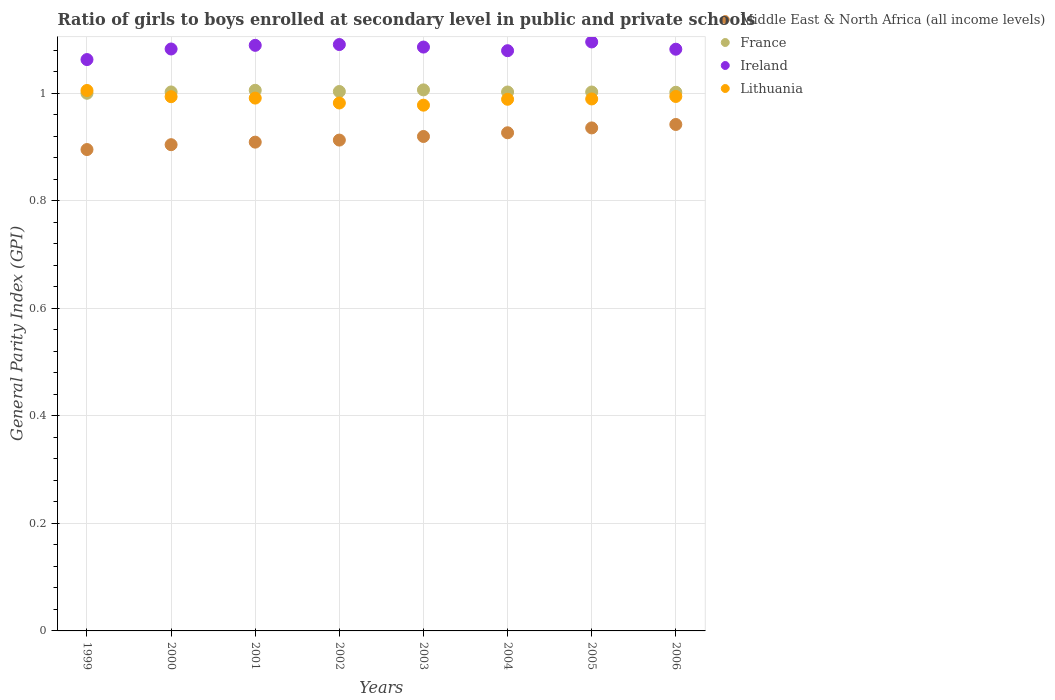How many different coloured dotlines are there?
Your answer should be very brief. 4. What is the general parity index in France in 2000?
Keep it short and to the point. 1. Across all years, what is the maximum general parity index in Middle East & North Africa (all income levels)?
Your response must be concise. 0.94. Across all years, what is the minimum general parity index in Ireland?
Provide a short and direct response. 1.06. What is the total general parity index in France in the graph?
Provide a succinct answer. 8.02. What is the difference between the general parity index in Ireland in 2002 and that in 2005?
Offer a terse response. -0. What is the difference between the general parity index in Ireland in 2006 and the general parity index in Middle East & North Africa (all income levels) in 2002?
Your answer should be very brief. 0.17. What is the average general parity index in Middle East & North Africa (all income levels) per year?
Make the answer very short. 0.92. In the year 2000, what is the difference between the general parity index in Lithuania and general parity index in Ireland?
Make the answer very short. -0.09. In how many years, is the general parity index in France greater than 0.9600000000000001?
Offer a very short reply. 8. What is the ratio of the general parity index in France in 2000 to that in 2001?
Offer a very short reply. 1. Is the difference between the general parity index in Lithuania in 1999 and 2001 greater than the difference between the general parity index in Ireland in 1999 and 2001?
Your response must be concise. Yes. What is the difference between the highest and the second highest general parity index in Lithuania?
Give a very brief answer. 0.01. What is the difference between the highest and the lowest general parity index in France?
Offer a terse response. 0.01. Is the sum of the general parity index in Lithuania in 2000 and 2006 greater than the maximum general parity index in France across all years?
Provide a short and direct response. Yes. Is it the case that in every year, the sum of the general parity index in Lithuania and general parity index in France  is greater than the sum of general parity index in Middle East & North Africa (all income levels) and general parity index in Ireland?
Make the answer very short. No. Is it the case that in every year, the sum of the general parity index in France and general parity index in Middle East & North Africa (all income levels)  is greater than the general parity index in Ireland?
Your response must be concise. Yes. Is the general parity index in Lithuania strictly less than the general parity index in Middle East & North Africa (all income levels) over the years?
Ensure brevity in your answer.  No. How many dotlines are there?
Your response must be concise. 4. Does the graph contain grids?
Your answer should be compact. Yes. Where does the legend appear in the graph?
Offer a terse response. Top right. How many legend labels are there?
Give a very brief answer. 4. How are the legend labels stacked?
Give a very brief answer. Vertical. What is the title of the graph?
Provide a succinct answer. Ratio of girls to boys enrolled at secondary level in public and private schools. Does "Gabon" appear as one of the legend labels in the graph?
Your response must be concise. No. What is the label or title of the X-axis?
Provide a short and direct response. Years. What is the label or title of the Y-axis?
Your answer should be compact. General Parity Index (GPI). What is the General Parity Index (GPI) of Middle East & North Africa (all income levels) in 1999?
Ensure brevity in your answer.  0.9. What is the General Parity Index (GPI) in France in 1999?
Your answer should be very brief. 1. What is the General Parity Index (GPI) in Ireland in 1999?
Offer a very short reply. 1.06. What is the General Parity Index (GPI) of Lithuania in 1999?
Offer a very short reply. 1. What is the General Parity Index (GPI) in Middle East & North Africa (all income levels) in 2000?
Keep it short and to the point. 0.9. What is the General Parity Index (GPI) of France in 2000?
Give a very brief answer. 1. What is the General Parity Index (GPI) in Ireland in 2000?
Give a very brief answer. 1.08. What is the General Parity Index (GPI) in Lithuania in 2000?
Offer a terse response. 0.99. What is the General Parity Index (GPI) of Middle East & North Africa (all income levels) in 2001?
Your answer should be compact. 0.91. What is the General Parity Index (GPI) in France in 2001?
Provide a short and direct response. 1.01. What is the General Parity Index (GPI) in Ireland in 2001?
Provide a succinct answer. 1.09. What is the General Parity Index (GPI) in Lithuania in 2001?
Provide a short and direct response. 0.99. What is the General Parity Index (GPI) of Middle East & North Africa (all income levels) in 2002?
Keep it short and to the point. 0.91. What is the General Parity Index (GPI) of France in 2002?
Offer a very short reply. 1. What is the General Parity Index (GPI) in Ireland in 2002?
Make the answer very short. 1.09. What is the General Parity Index (GPI) of Lithuania in 2002?
Make the answer very short. 0.98. What is the General Parity Index (GPI) of Middle East & North Africa (all income levels) in 2003?
Provide a short and direct response. 0.92. What is the General Parity Index (GPI) in France in 2003?
Provide a short and direct response. 1.01. What is the General Parity Index (GPI) of Ireland in 2003?
Provide a succinct answer. 1.09. What is the General Parity Index (GPI) in Lithuania in 2003?
Give a very brief answer. 0.98. What is the General Parity Index (GPI) in Middle East & North Africa (all income levels) in 2004?
Your answer should be very brief. 0.93. What is the General Parity Index (GPI) in France in 2004?
Your answer should be compact. 1. What is the General Parity Index (GPI) of Ireland in 2004?
Your answer should be very brief. 1.08. What is the General Parity Index (GPI) in Lithuania in 2004?
Keep it short and to the point. 0.99. What is the General Parity Index (GPI) of Middle East & North Africa (all income levels) in 2005?
Make the answer very short. 0.94. What is the General Parity Index (GPI) of France in 2005?
Provide a succinct answer. 1. What is the General Parity Index (GPI) of Ireland in 2005?
Your answer should be very brief. 1.1. What is the General Parity Index (GPI) in Lithuania in 2005?
Your answer should be very brief. 0.99. What is the General Parity Index (GPI) of Middle East & North Africa (all income levels) in 2006?
Your answer should be very brief. 0.94. What is the General Parity Index (GPI) in France in 2006?
Provide a short and direct response. 1. What is the General Parity Index (GPI) in Ireland in 2006?
Your answer should be very brief. 1.08. What is the General Parity Index (GPI) in Lithuania in 2006?
Offer a very short reply. 0.99. Across all years, what is the maximum General Parity Index (GPI) in Middle East & North Africa (all income levels)?
Make the answer very short. 0.94. Across all years, what is the maximum General Parity Index (GPI) in France?
Your answer should be very brief. 1.01. Across all years, what is the maximum General Parity Index (GPI) in Ireland?
Your answer should be compact. 1.1. Across all years, what is the maximum General Parity Index (GPI) in Lithuania?
Provide a succinct answer. 1. Across all years, what is the minimum General Parity Index (GPI) of Middle East & North Africa (all income levels)?
Offer a very short reply. 0.9. Across all years, what is the minimum General Parity Index (GPI) in France?
Your answer should be very brief. 1. Across all years, what is the minimum General Parity Index (GPI) of Ireland?
Offer a very short reply. 1.06. Across all years, what is the minimum General Parity Index (GPI) of Lithuania?
Offer a very short reply. 0.98. What is the total General Parity Index (GPI) of Middle East & North Africa (all income levels) in the graph?
Ensure brevity in your answer.  7.34. What is the total General Parity Index (GPI) in France in the graph?
Offer a terse response. 8.02. What is the total General Parity Index (GPI) of Ireland in the graph?
Provide a succinct answer. 8.66. What is the total General Parity Index (GPI) of Lithuania in the graph?
Make the answer very short. 7.92. What is the difference between the General Parity Index (GPI) in Middle East & North Africa (all income levels) in 1999 and that in 2000?
Your answer should be very brief. -0.01. What is the difference between the General Parity Index (GPI) of France in 1999 and that in 2000?
Offer a terse response. -0. What is the difference between the General Parity Index (GPI) in Ireland in 1999 and that in 2000?
Provide a succinct answer. -0.02. What is the difference between the General Parity Index (GPI) in Lithuania in 1999 and that in 2000?
Keep it short and to the point. 0.01. What is the difference between the General Parity Index (GPI) in Middle East & North Africa (all income levels) in 1999 and that in 2001?
Provide a short and direct response. -0.01. What is the difference between the General Parity Index (GPI) in France in 1999 and that in 2001?
Provide a short and direct response. -0.01. What is the difference between the General Parity Index (GPI) in Ireland in 1999 and that in 2001?
Offer a very short reply. -0.03. What is the difference between the General Parity Index (GPI) of Lithuania in 1999 and that in 2001?
Ensure brevity in your answer.  0.01. What is the difference between the General Parity Index (GPI) of Middle East & North Africa (all income levels) in 1999 and that in 2002?
Your response must be concise. -0.02. What is the difference between the General Parity Index (GPI) in France in 1999 and that in 2002?
Provide a short and direct response. -0. What is the difference between the General Parity Index (GPI) in Ireland in 1999 and that in 2002?
Your answer should be compact. -0.03. What is the difference between the General Parity Index (GPI) of Lithuania in 1999 and that in 2002?
Provide a succinct answer. 0.02. What is the difference between the General Parity Index (GPI) of Middle East & North Africa (all income levels) in 1999 and that in 2003?
Offer a terse response. -0.02. What is the difference between the General Parity Index (GPI) of France in 1999 and that in 2003?
Provide a short and direct response. -0.01. What is the difference between the General Parity Index (GPI) of Ireland in 1999 and that in 2003?
Ensure brevity in your answer.  -0.02. What is the difference between the General Parity Index (GPI) of Lithuania in 1999 and that in 2003?
Your response must be concise. 0.03. What is the difference between the General Parity Index (GPI) of Middle East & North Africa (all income levels) in 1999 and that in 2004?
Offer a terse response. -0.03. What is the difference between the General Parity Index (GPI) of France in 1999 and that in 2004?
Keep it short and to the point. -0. What is the difference between the General Parity Index (GPI) of Ireland in 1999 and that in 2004?
Provide a succinct answer. -0.02. What is the difference between the General Parity Index (GPI) of Lithuania in 1999 and that in 2004?
Offer a very short reply. 0.02. What is the difference between the General Parity Index (GPI) in Middle East & North Africa (all income levels) in 1999 and that in 2005?
Offer a very short reply. -0.04. What is the difference between the General Parity Index (GPI) in France in 1999 and that in 2005?
Give a very brief answer. -0. What is the difference between the General Parity Index (GPI) of Ireland in 1999 and that in 2005?
Offer a terse response. -0.03. What is the difference between the General Parity Index (GPI) in Lithuania in 1999 and that in 2005?
Your answer should be very brief. 0.02. What is the difference between the General Parity Index (GPI) in Middle East & North Africa (all income levels) in 1999 and that in 2006?
Provide a succinct answer. -0.05. What is the difference between the General Parity Index (GPI) of France in 1999 and that in 2006?
Make the answer very short. -0. What is the difference between the General Parity Index (GPI) of Ireland in 1999 and that in 2006?
Provide a short and direct response. -0.02. What is the difference between the General Parity Index (GPI) in Lithuania in 1999 and that in 2006?
Provide a succinct answer. 0.01. What is the difference between the General Parity Index (GPI) of Middle East & North Africa (all income levels) in 2000 and that in 2001?
Your answer should be compact. -0. What is the difference between the General Parity Index (GPI) of France in 2000 and that in 2001?
Offer a very short reply. -0. What is the difference between the General Parity Index (GPI) of Ireland in 2000 and that in 2001?
Your response must be concise. -0.01. What is the difference between the General Parity Index (GPI) of Lithuania in 2000 and that in 2001?
Ensure brevity in your answer.  0. What is the difference between the General Parity Index (GPI) in Middle East & North Africa (all income levels) in 2000 and that in 2002?
Keep it short and to the point. -0.01. What is the difference between the General Parity Index (GPI) of France in 2000 and that in 2002?
Keep it short and to the point. -0. What is the difference between the General Parity Index (GPI) of Ireland in 2000 and that in 2002?
Make the answer very short. -0.01. What is the difference between the General Parity Index (GPI) in Lithuania in 2000 and that in 2002?
Offer a terse response. 0.01. What is the difference between the General Parity Index (GPI) in Middle East & North Africa (all income levels) in 2000 and that in 2003?
Ensure brevity in your answer.  -0.02. What is the difference between the General Parity Index (GPI) in France in 2000 and that in 2003?
Keep it short and to the point. -0. What is the difference between the General Parity Index (GPI) in Ireland in 2000 and that in 2003?
Offer a terse response. -0. What is the difference between the General Parity Index (GPI) in Lithuania in 2000 and that in 2003?
Offer a terse response. 0.02. What is the difference between the General Parity Index (GPI) in Middle East & North Africa (all income levels) in 2000 and that in 2004?
Offer a very short reply. -0.02. What is the difference between the General Parity Index (GPI) in France in 2000 and that in 2004?
Provide a succinct answer. 0. What is the difference between the General Parity Index (GPI) in Ireland in 2000 and that in 2004?
Your answer should be very brief. 0. What is the difference between the General Parity Index (GPI) of Lithuania in 2000 and that in 2004?
Ensure brevity in your answer.  0. What is the difference between the General Parity Index (GPI) in Middle East & North Africa (all income levels) in 2000 and that in 2005?
Provide a short and direct response. -0.03. What is the difference between the General Parity Index (GPI) in Ireland in 2000 and that in 2005?
Ensure brevity in your answer.  -0.01. What is the difference between the General Parity Index (GPI) in Lithuania in 2000 and that in 2005?
Give a very brief answer. 0. What is the difference between the General Parity Index (GPI) of Middle East & North Africa (all income levels) in 2000 and that in 2006?
Your response must be concise. -0.04. What is the difference between the General Parity Index (GPI) of Lithuania in 2000 and that in 2006?
Your response must be concise. -0. What is the difference between the General Parity Index (GPI) in Middle East & North Africa (all income levels) in 2001 and that in 2002?
Make the answer very short. -0. What is the difference between the General Parity Index (GPI) in France in 2001 and that in 2002?
Your answer should be very brief. 0. What is the difference between the General Parity Index (GPI) of Ireland in 2001 and that in 2002?
Make the answer very short. -0. What is the difference between the General Parity Index (GPI) of Lithuania in 2001 and that in 2002?
Give a very brief answer. 0.01. What is the difference between the General Parity Index (GPI) of Middle East & North Africa (all income levels) in 2001 and that in 2003?
Keep it short and to the point. -0.01. What is the difference between the General Parity Index (GPI) of France in 2001 and that in 2003?
Give a very brief answer. -0. What is the difference between the General Parity Index (GPI) in Ireland in 2001 and that in 2003?
Your answer should be very brief. 0. What is the difference between the General Parity Index (GPI) of Lithuania in 2001 and that in 2003?
Your response must be concise. 0.01. What is the difference between the General Parity Index (GPI) in Middle East & North Africa (all income levels) in 2001 and that in 2004?
Ensure brevity in your answer.  -0.02. What is the difference between the General Parity Index (GPI) of France in 2001 and that in 2004?
Provide a succinct answer. 0. What is the difference between the General Parity Index (GPI) of Ireland in 2001 and that in 2004?
Provide a succinct answer. 0.01. What is the difference between the General Parity Index (GPI) in Lithuania in 2001 and that in 2004?
Offer a very short reply. 0. What is the difference between the General Parity Index (GPI) in Middle East & North Africa (all income levels) in 2001 and that in 2005?
Your answer should be compact. -0.03. What is the difference between the General Parity Index (GPI) of France in 2001 and that in 2005?
Your answer should be very brief. 0. What is the difference between the General Parity Index (GPI) of Ireland in 2001 and that in 2005?
Offer a terse response. -0.01. What is the difference between the General Parity Index (GPI) in Lithuania in 2001 and that in 2005?
Ensure brevity in your answer.  0. What is the difference between the General Parity Index (GPI) of Middle East & North Africa (all income levels) in 2001 and that in 2006?
Your answer should be compact. -0.03. What is the difference between the General Parity Index (GPI) of France in 2001 and that in 2006?
Keep it short and to the point. 0. What is the difference between the General Parity Index (GPI) in Ireland in 2001 and that in 2006?
Your answer should be very brief. 0.01. What is the difference between the General Parity Index (GPI) of Lithuania in 2001 and that in 2006?
Provide a succinct answer. -0. What is the difference between the General Parity Index (GPI) of Middle East & North Africa (all income levels) in 2002 and that in 2003?
Offer a very short reply. -0.01. What is the difference between the General Parity Index (GPI) of France in 2002 and that in 2003?
Keep it short and to the point. -0. What is the difference between the General Parity Index (GPI) of Ireland in 2002 and that in 2003?
Offer a very short reply. 0. What is the difference between the General Parity Index (GPI) of Lithuania in 2002 and that in 2003?
Your answer should be very brief. 0. What is the difference between the General Parity Index (GPI) in Middle East & North Africa (all income levels) in 2002 and that in 2004?
Provide a short and direct response. -0.01. What is the difference between the General Parity Index (GPI) of France in 2002 and that in 2004?
Your answer should be compact. 0. What is the difference between the General Parity Index (GPI) of Ireland in 2002 and that in 2004?
Keep it short and to the point. 0.01. What is the difference between the General Parity Index (GPI) in Lithuania in 2002 and that in 2004?
Offer a terse response. -0.01. What is the difference between the General Parity Index (GPI) of Middle East & North Africa (all income levels) in 2002 and that in 2005?
Give a very brief answer. -0.02. What is the difference between the General Parity Index (GPI) of France in 2002 and that in 2005?
Offer a very short reply. 0. What is the difference between the General Parity Index (GPI) of Ireland in 2002 and that in 2005?
Your answer should be compact. -0. What is the difference between the General Parity Index (GPI) in Lithuania in 2002 and that in 2005?
Provide a short and direct response. -0.01. What is the difference between the General Parity Index (GPI) of Middle East & North Africa (all income levels) in 2002 and that in 2006?
Offer a very short reply. -0.03. What is the difference between the General Parity Index (GPI) of France in 2002 and that in 2006?
Ensure brevity in your answer.  0. What is the difference between the General Parity Index (GPI) in Ireland in 2002 and that in 2006?
Provide a succinct answer. 0.01. What is the difference between the General Parity Index (GPI) of Lithuania in 2002 and that in 2006?
Your answer should be compact. -0.01. What is the difference between the General Parity Index (GPI) of Middle East & North Africa (all income levels) in 2003 and that in 2004?
Provide a succinct answer. -0.01. What is the difference between the General Parity Index (GPI) in France in 2003 and that in 2004?
Your response must be concise. 0. What is the difference between the General Parity Index (GPI) in Ireland in 2003 and that in 2004?
Offer a terse response. 0.01. What is the difference between the General Parity Index (GPI) in Lithuania in 2003 and that in 2004?
Offer a terse response. -0.01. What is the difference between the General Parity Index (GPI) in Middle East & North Africa (all income levels) in 2003 and that in 2005?
Make the answer very short. -0.02. What is the difference between the General Parity Index (GPI) of France in 2003 and that in 2005?
Ensure brevity in your answer.  0. What is the difference between the General Parity Index (GPI) in Ireland in 2003 and that in 2005?
Offer a very short reply. -0.01. What is the difference between the General Parity Index (GPI) in Lithuania in 2003 and that in 2005?
Keep it short and to the point. -0.01. What is the difference between the General Parity Index (GPI) of Middle East & North Africa (all income levels) in 2003 and that in 2006?
Make the answer very short. -0.02. What is the difference between the General Parity Index (GPI) in France in 2003 and that in 2006?
Provide a short and direct response. 0. What is the difference between the General Parity Index (GPI) in Ireland in 2003 and that in 2006?
Make the answer very short. 0. What is the difference between the General Parity Index (GPI) in Lithuania in 2003 and that in 2006?
Ensure brevity in your answer.  -0.02. What is the difference between the General Parity Index (GPI) of Middle East & North Africa (all income levels) in 2004 and that in 2005?
Offer a terse response. -0.01. What is the difference between the General Parity Index (GPI) in Ireland in 2004 and that in 2005?
Offer a very short reply. -0.02. What is the difference between the General Parity Index (GPI) of Lithuania in 2004 and that in 2005?
Provide a succinct answer. -0. What is the difference between the General Parity Index (GPI) in Middle East & North Africa (all income levels) in 2004 and that in 2006?
Offer a terse response. -0.02. What is the difference between the General Parity Index (GPI) of France in 2004 and that in 2006?
Give a very brief answer. 0. What is the difference between the General Parity Index (GPI) of Ireland in 2004 and that in 2006?
Your answer should be very brief. -0. What is the difference between the General Parity Index (GPI) in Lithuania in 2004 and that in 2006?
Your answer should be compact. -0.01. What is the difference between the General Parity Index (GPI) of Middle East & North Africa (all income levels) in 2005 and that in 2006?
Provide a short and direct response. -0.01. What is the difference between the General Parity Index (GPI) of France in 2005 and that in 2006?
Make the answer very short. 0. What is the difference between the General Parity Index (GPI) in Ireland in 2005 and that in 2006?
Make the answer very short. 0.01. What is the difference between the General Parity Index (GPI) in Lithuania in 2005 and that in 2006?
Ensure brevity in your answer.  -0. What is the difference between the General Parity Index (GPI) in Middle East & North Africa (all income levels) in 1999 and the General Parity Index (GPI) in France in 2000?
Keep it short and to the point. -0.11. What is the difference between the General Parity Index (GPI) of Middle East & North Africa (all income levels) in 1999 and the General Parity Index (GPI) of Ireland in 2000?
Offer a very short reply. -0.19. What is the difference between the General Parity Index (GPI) of Middle East & North Africa (all income levels) in 1999 and the General Parity Index (GPI) of Lithuania in 2000?
Keep it short and to the point. -0.1. What is the difference between the General Parity Index (GPI) in France in 1999 and the General Parity Index (GPI) in Ireland in 2000?
Keep it short and to the point. -0.08. What is the difference between the General Parity Index (GPI) in France in 1999 and the General Parity Index (GPI) in Lithuania in 2000?
Keep it short and to the point. 0.01. What is the difference between the General Parity Index (GPI) of Ireland in 1999 and the General Parity Index (GPI) of Lithuania in 2000?
Provide a succinct answer. 0.07. What is the difference between the General Parity Index (GPI) in Middle East & North Africa (all income levels) in 1999 and the General Parity Index (GPI) in France in 2001?
Give a very brief answer. -0.11. What is the difference between the General Parity Index (GPI) of Middle East & North Africa (all income levels) in 1999 and the General Parity Index (GPI) of Ireland in 2001?
Your answer should be compact. -0.19. What is the difference between the General Parity Index (GPI) of Middle East & North Africa (all income levels) in 1999 and the General Parity Index (GPI) of Lithuania in 2001?
Make the answer very short. -0.1. What is the difference between the General Parity Index (GPI) in France in 1999 and the General Parity Index (GPI) in Ireland in 2001?
Your answer should be compact. -0.09. What is the difference between the General Parity Index (GPI) in France in 1999 and the General Parity Index (GPI) in Lithuania in 2001?
Offer a terse response. 0.01. What is the difference between the General Parity Index (GPI) of Ireland in 1999 and the General Parity Index (GPI) of Lithuania in 2001?
Your response must be concise. 0.07. What is the difference between the General Parity Index (GPI) in Middle East & North Africa (all income levels) in 1999 and the General Parity Index (GPI) in France in 2002?
Your answer should be very brief. -0.11. What is the difference between the General Parity Index (GPI) of Middle East & North Africa (all income levels) in 1999 and the General Parity Index (GPI) of Ireland in 2002?
Provide a short and direct response. -0.2. What is the difference between the General Parity Index (GPI) in Middle East & North Africa (all income levels) in 1999 and the General Parity Index (GPI) in Lithuania in 2002?
Your answer should be compact. -0.09. What is the difference between the General Parity Index (GPI) of France in 1999 and the General Parity Index (GPI) of Ireland in 2002?
Offer a very short reply. -0.09. What is the difference between the General Parity Index (GPI) of France in 1999 and the General Parity Index (GPI) of Lithuania in 2002?
Provide a succinct answer. 0.02. What is the difference between the General Parity Index (GPI) in Ireland in 1999 and the General Parity Index (GPI) in Lithuania in 2002?
Make the answer very short. 0.08. What is the difference between the General Parity Index (GPI) of Middle East & North Africa (all income levels) in 1999 and the General Parity Index (GPI) of France in 2003?
Give a very brief answer. -0.11. What is the difference between the General Parity Index (GPI) of Middle East & North Africa (all income levels) in 1999 and the General Parity Index (GPI) of Ireland in 2003?
Give a very brief answer. -0.19. What is the difference between the General Parity Index (GPI) in Middle East & North Africa (all income levels) in 1999 and the General Parity Index (GPI) in Lithuania in 2003?
Make the answer very short. -0.08. What is the difference between the General Parity Index (GPI) of France in 1999 and the General Parity Index (GPI) of Ireland in 2003?
Give a very brief answer. -0.09. What is the difference between the General Parity Index (GPI) of France in 1999 and the General Parity Index (GPI) of Lithuania in 2003?
Your answer should be compact. 0.02. What is the difference between the General Parity Index (GPI) of Ireland in 1999 and the General Parity Index (GPI) of Lithuania in 2003?
Offer a very short reply. 0.08. What is the difference between the General Parity Index (GPI) of Middle East & North Africa (all income levels) in 1999 and the General Parity Index (GPI) of France in 2004?
Your response must be concise. -0.11. What is the difference between the General Parity Index (GPI) of Middle East & North Africa (all income levels) in 1999 and the General Parity Index (GPI) of Ireland in 2004?
Your answer should be very brief. -0.18. What is the difference between the General Parity Index (GPI) of Middle East & North Africa (all income levels) in 1999 and the General Parity Index (GPI) of Lithuania in 2004?
Make the answer very short. -0.09. What is the difference between the General Parity Index (GPI) in France in 1999 and the General Parity Index (GPI) in Ireland in 2004?
Provide a short and direct response. -0.08. What is the difference between the General Parity Index (GPI) in France in 1999 and the General Parity Index (GPI) in Lithuania in 2004?
Offer a terse response. 0.01. What is the difference between the General Parity Index (GPI) in Ireland in 1999 and the General Parity Index (GPI) in Lithuania in 2004?
Make the answer very short. 0.07. What is the difference between the General Parity Index (GPI) in Middle East & North Africa (all income levels) in 1999 and the General Parity Index (GPI) in France in 2005?
Provide a succinct answer. -0.11. What is the difference between the General Parity Index (GPI) of Middle East & North Africa (all income levels) in 1999 and the General Parity Index (GPI) of Ireland in 2005?
Ensure brevity in your answer.  -0.2. What is the difference between the General Parity Index (GPI) of Middle East & North Africa (all income levels) in 1999 and the General Parity Index (GPI) of Lithuania in 2005?
Your answer should be very brief. -0.09. What is the difference between the General Parity Index (GPI) of France in 1999 and the General Parity Index (GPI) of Ireland in 2005?
Make the answer very short. -0.1. What is the difference between the General Parity Index (GPI) of France in 1999 and the General Parity Index (GPI) of Lithuania in 2005?
Offer a terse response. 0.01. What is the difference between the General Parity Index (GPI) of Ireland in 1999 and the General Parity Index (GPI) of Lithuania in 2005?
Provide a succinct answer. 0.07. What is the difference between the General Parity Index (GPI) of Middle East & North Africa (all income levels) in 1999 and the General Parity Index (GPI) of France in 2006?
Your response must be concise. -0.11. What is the difference between the General Parity Index (GPI) of Middle East & North Africa (all income levels) in 1999 and the General Parity Index (GPI) of Ireland in 2006?
Your answer should be compact. -0.19. What is the difference between the General Parity Index (GPI) in Middle East & North Africa (all income levels) in 1999 and the General Parity Index (GPI) in Lithuania in 2006?
Offer a very short reply. -0.1. What is the difference between the General Parity Index (GPI) of France in 1999 and the General Parity Index (GPI) of Ireland in 2006?
Keep it short and to the point. -0.08. What is the difference between the General Parity Index (GPI) of France in 1999 and the General Parity Index (GPI) of Lithuania in 2006?
Offer a very short reply. 0.01. What is the difference between the General Parity Index (GPI) in Ireland in 1999 and the General Parity Index (GPI) in Lithuania in 2006?
Make the answer very short. 0.07. What is the difference between the General Parity Index (GPI) of Middle East & North Africa (all income levels) in 2000 and the General Parity Index (GPI) of France in 2001?
Give a very brief answer. -0.1. What is the difference between the General Parity Index (GPI) of Middle East & North Africa (all income levels) in 2000 and the General Parity Index (GPI) of Ireland in 2001?
Provide a succinct answer. -0.18. What is the difference between the General Parity Index (GPI) of Middle East & North Africa (all income levels) in 2000 and the General Parity Index (GPI) of Lithuania in 2001?
Your answer should be compact. -0.09. What is the difference between the General Parity Index (GPI) of France in 2000 and the General Parity Index (GPI) of Ireland in 2001?
Provide a succinct answer. -0.09. What is the difference between the General Parity Index (GPI) in France in 2000 and the General Parity Index (GPI) in Lithuania in 2001?
Ensure brevity in your answer.  0.01. What is the difference between the General Parity Index (GPI) of Ireland in 2000 and the General Parity Index (GPI) of Lithuania in 2001?
Offer a terse response. 0.09. What is the difference between the General Parity Index (GPI) in Middle East & North Africa (all income levels) in 2000 and the General Parity Index (GPI) in France in 2002?
Provide a succinct answer. -0.1. What is the difference between the General Parity Index (GPI) in Middle East & North Africa (all income levels) in 2000 and the General Parity Index (GPI) in Ireland in 2002?
Offer a very short reply. -0.19. What is the difference between the General Parity Index (GPI) of Middle East & North Africa (all income levels) in 2000 and the General Parity Index (GPI) of Lithuania in 2002?
Ensure brevity in your answer.  -0.08. What is the difference between the General Parity Index (GPI) of France in 2000 and the General Parity Index (GPI) of Ireland in 2002?
Provide a succinct answer. -0.09. What is the difference between the General Parity Index (GPI) in France in 2000 and the General Parity Index (GPI) in Lithuania in 2002?
Provide a succinct answer. 0.02. What is the difference between the General Parity Index (GPI) in Ireland in 2000 and the General Parity Index (GPI) in Lithuania in 2002?
Ensure brevity in your answer.  0.1. What is the difference between the General Parity Index (GPI) in Middle East & North Africa (all income levels) in 2000 and the General Parity Index (GPI) in France in 2003?
Your answer should be very brief. -0.1. What is the difference between the General Parity Index (GPI) in Middle East & North Africa (all income levels) in 2000 and the General Parity Index (GPI) in Ireland in 2003?
Ensure brevity in your answer.  -0.18. What is the difference between the General Parity Index (GPI) in Middle East & North Africa (all income levels) in 2000 and the General Parity Index (GPI) in Lithuania in 2003?
Give a very brief answer. -0.07. What is the difference between the General Parity Index (GPI) in France in 2000 and the General Parity Index (GPI) in Ireland in 2003?
Offer a terse response. -0.08. What is the difference between the General Parity Index (GPI) in France in 2000 and the General Parity Index (GPI) in Lithuania in 2003?
Offer a very short reply. 0.02. What is the difference between the General Parity Index (GPI) in Ireland in 2000 and the General Parity Index (GPI) in Lithuania in 2003?
Provide a short and direct response. 0.1. What is the difference between the General Parity Index (GPI) of Middle East & North Africa (all income levels) in 2000 and the General Parity Index (GPI) of France in 2004?
Your answer should be compact. -0.1. What is the difference between the General Parity Index (GPI) in Middle East & North Africa (all income levels) in 2000 and the General Parity Index (GPI) in Ireland in 2004?
Your response must be concise. -0.17. What is the difference between the General Parity Index (GPI) in Middle East & North Africa (all income levels) in 2000 and the General Parity Index (GPI) in Lithuania in 2004?
Provide a succinct answer. -0.08. What is the difference between the General Parity Index (GPI) of France in 2000 and the General Parity Index (GPI) of Ireland in 2004?
Your response must be concise. -0.08. What is the difference between the General Parity Index (GPI) of France in 2000 and the General Parity Index (GPI) of Lithuania in 2004?
Provide a succinct answer. 0.01. What is the difference between the General Parity Index (GPI) of Ireland in 2000 and the General Parity Index (GPI) of Lithuania in 2004?
Your answer should be compact. 0.09. What is the difference between the General Parity Index (GPI) of Middle East & North Africa (all income levels) in 2000 and the General Parity Index (GPI) of France in 2005?
Provide a succinct answer. -0.1. What is the difference between the General Parity Index (GPI) in Middle East & North Africa (all income levels) in 2000 and the General Parity Index (GPI) in Ireland in 2005?
Provide a succinct answer. -0.19. What is the difference between the General Parity Index (GPI) of Middle East & North Africa (all income levels) in 2000 and the General Parity Index (GPI) of Lithuania in 2005?
Give a very brief answer. -0.09. What is the difference between the General Parity Index (GPI) of France in 2000 and the General Parity Index (GPI) of Ireland in 2005?
Ensure brevity in your answer.  -0.09. What is the difference between the General Parity Index (GPI) of France in 2000 and the General Parity Index (GPI) of Lithuania in 2005?
Keep it short and to the point. 0.01. What is the difference between the General Parity Index (GPI) in Ireland in 2000 and the General Parity Index (GPI) in Lithuania in 2005?
Offer a very short reply. 0.09. What is the difference between the General Parity Index (GPI) in Middle East & North Africa (all income levels) in 2000 and the General Parity Index (GPI) in France in 2006?
Your answer should be very brief. -0.1. What is the difference between the General Parity Index (GPI) of Middle East & North Africa (all income levels) in 2000 and the General Parity Index (GPI) of Ireland in 2006?
Your answer should be compact. -0.18. What is the difference between the General Parity Index (GPI) of Middle East & North Africa (all income levels) in 2000 and the General Parity Index (GPI) of Lithuania in 2006?
Your answer should be very brief. -0.09. What is the difference between the General Parity Index (GPI) in France in 2000 and the General Parity Index (GPI) in Ireland in 2006?
Keep it short and to the point. -0.08. What is the difference between the General Parity Index (GPI) in France in 2000 and the General Parity Index (GPI) in Lithuania in 2006?
Give a very brief answer. 0.01. What is the difference between the General Parity Index (GPI) of Ireland in 2000 and the General Parity Index (GPI) of Lithuania in 2006?
Your answer should be very brief. 0.09. What is the difference between the General Parity Index (GPI) of Middle East & North Africa (all income levels) in 2001 and the General Parity Index (GPI) of France in 2002?
Provide a short and direct response. -0.09. What is the difference between the General Parity Index (GPI) of Middle East & North Africa (all income levels) in 2001 and the General Parity Index (GPI) of Ireland in 2002?
Keep it short and to the point. -0.18. What is the difference between the General Parity Index (GPI) of Middle East & North Africa (all income levels) in 2001 and the General Parity Index (GPI) of Lithuania in 2002?
Give a very brief answer. -0.07. What is the difference between the General Parity Index (GPI) of France in 2001 and the General Parity Index (GPI) of Ireland in 2002?
Provide a short and direct response. -0.09. What is the difference between the General Parity Index (GPI) in France in 2001 and the General Parity Index (GPI) in Lithuania in 2002?
Provide a short and direct response. 0.02. What is the difference between the General Parity Index (GPI) of Ireland in 2001 and the General Parity Index (GPI) of Lithuania in 2002?
Make the answer very short. 0.11. What is the difference between the General Parity Index (GPI) in Middle East & North Africa (all income levels) in 2001 and the General Parity Index (GPI) in France in 2003?
Provide a short and direct response. -0.1. What is the difference between the General Parity Index (GPI) of Middle East & North Africa (all income levels) in 2001 and the General Parity Index (GPI) of Ireland in 2003?
Provide a succinct answer. -0.18. What is the difference between the General Parity Index (GPI) of Middle East & North Africa (all income levels) in 2001 and the General Parity Index (GPI) of Lithuania in 2003?
Offer a terse response. -0.07. What is the difference between the General Parity Index (GPI) in France in 2001 and the General Parity Index (GPI) in Ireland in 2003?
Offer a very short reply. -0.08. What is the difference between the General Parity Index (GPI) of France in 2001 and the General Parity Index (GPI) of Lithuania in 2003?
Provide a succinct answer. 0.03. What is the difference between the General Parity Index (GPI) of Ireland in 2001 and the General Parity Index (GPI) of Lithuania in 2003?
Make the answer very short. 0.11. What is the difference between the General Parity Index (GPI) in Middle East & North Africa (all income levels) in 2001 and the General Parity Index (GPI) in France in 2004?
Give a very brief answer. -0.09. What is the difference between the General Parity Index (GPI) of Middle East & North Africa (all income levels) in 2001 and the General Parity Index (GPI) of Ireland in 2004?
Provide a short and direct response. -0.17. What is the difference between the General Parity Index (GPI) of Middle East & North Africa (all income levels) in 2001 and the General Parity Index (GPI) of Lithuania in 2004?
Ensure brevity in your answer.  -0.08. What is the difference between the General Parity Index (GPI) in France in 2001 and the General Parity Index (GPI) in Ireland in 2004?
Keep it short and to the point. -0.07. What is the difference between the General Parity Index (GPI) of France in 2001 and the General Parity Index (GPI) of Lithuania in 2004?
Provide a succinct answer. 0.02. What is the difference between the General Parity Index (GPI) in Ireland in 2001 and the General Parity Index (GPI) in Lithuania in 2004?
Your response must be concise. 0.1. What is the difference between the General Parity Index (GPI) of Middle East & North Africa (all income levels) in 2001 and the General Parity Index (GPI) of France in 2005?
Your answer should be compact. -0.09. What is the difference between the General Parity Index (GPI) in Middle East & North Africa (all income levels) in 2001 and the General Parity Index (GPI) in Ireland in 2005?
Provide a short and direct response. -0.19. What is the difference between the General Parity Index (GPI) in Middle East & North Africa (all income levels) in 2001 and the General Parity Index (GPI) in Lithuania in 2005?
Provide a short and direct response. -0.08. What is the difference between the General Parity Index (GPI) in France in 2001 and the General Parity Index (GPI) in Ireland in 2005?
Your answer should be very brief. -0.09. What is the difference between the General Parity Index (GPI) in France in 2001 and the General Parity Index (GPI) in Lithuania in 2005?
Ensure brevity in your answer.  0.02. What is the difference between the General Parity Index (GPI) of Ireland in 2001 and the General Parity Index (GPI) of Lithuania in 2005?
Make the answer very short. 0.1. What is the difference between the General Parity Index (GPI) in Middle East & North Africa (all income levels) in 2001 and the General Parity Index (GPI) in France in 2006?
Provide a short and direct response. -0.09. What is the difference between the General Parity Index (GPI) of Middle East & North Africa (all income levels) in 2001 and the General Parity Index (GPI) of Ireland in 2006?
Offer a terse response. -0.17. What is the difference between the General Parity Index (GPI) in Middle East & North Africa (all income levels) in 2001 and the General Parity Index (GPI) in Lithuania in 2006?
Your answer should be very brief. -0.08. What is the difference between the General Parity Index (GPI) in France in 2001 and the General Parity Index (GPI) in Ireland in 2006?
Your answer should be compact. -0.08. What is the difference between the General Parity Index (GPI) in France in 2001 and the General Parity Index (GPI) in Lithuania in 2006?
Offer a terse response. 0.01. What is the difference between the General Parity Index (GPI) of Ireland in 2001 and the General Parity Index (GPI) of Lithuania in 2006?
Give a very brief answer. 0.1. What is the difference between the General Parity Index (GPI) of Middle East & North Africa (all income levels) in 2002 and the General Parity Index (GPI) of France in 2003?
Make the answer very short. -0.09. What is the difference between the General Parity Index (GPI) in Middle East & North Africa (all income levels) in 2002 and the General Parity Index (GPI) in Ireland in 2003?
Make the answer very short. -0.17. What is the difference between the General Parity Index (GPI) of Middle East & North Africa (all income levels) in 2002 and the General Parity Index (GPI) of Lithuania in 2003?
Offer a very short reply. -0.06. What is the difference between the General Parity Index (GPI) of France in 2002 and the General Parity Index (GPI) of Ireland in 2003?
Your response must be concise. -0.08. What is the difference between the General Parity Index (GPI) of France in 2002 and the General Parity Index (GPI) of Lithuania in 2003?
Keep it short and to the point. 0.03. What is the difference between the General Parity Index (GPI) of Ireland in 2002 and the General Parity Index (GPI) of Lithuania in 2003?
Offer a terse response. 0.11. What is the difference between the General Parity Index (GPI) of Middle East & North Africa (all income levels) in 2002 and the General Parity Index (GPI) of France in 2004?
Offer a terse response. -0.09. What is the difference between the General Parity Index (GPI) of Middle East & North Africa (all income levels) in 2002 and the General Parity Index (GPI) of Ireland in 2004?
Provide a short and direct response. -0.17. What is the difference between the General Parity Index (GPI) in Middle East & North Africa (all income levels) in 2002 and the General Parity Index (GPI) in Lithuania in 2004?
Make the answer very short. -0.08. What is the difference between the General Parity Index (GPI) in France in 2002 and the General Parity Index (GPI) in Ireland in 2004?
Provide a short and direct response. -0.08. What is the difference between the General Parity Index (GPI) of France in 2002 and the General Parity Index (GPI) of Lithuania in 2004?
Provide a succinct answer. 0.01. What is the difference between the General Parity Index (GPI) in Ireland in 2002 and the General Parity Index (GPI) in Lithuania in 2004?
Provide a short and direct response. 0.1. What is the difference between the General Parity Index (GPI) in Middle East & North Africa (all income levels) in 2002 and the General Parity Index (GPI) in France in 2005?
Your response must be concise. -0.09. What is the difference between the General Parity Index (GPI) in Middle East & North Africa (all income levels) in 2002 and the General Parity Index (GPI) in Ireland in 2005?
Your response must be concise. -0.18. What is the difference between the General Parity Index (GPI) of Middle East & North Africa (all income levels) in 2002 and the General Parity Index (GPI) of Lithuania in 2005?
Your response must be concise. -0.08. What is the difference between the General Parity Index (GPI) of France in 2002 and the General Parity Index (GPI) of Ireland in 2005?
Offer a very short reply. -0.09. What is the difference between the General Parity Index (GPI) in France in 2002 and the General Parity Index (GPI) in Lithuania in 2005?
Your response must be concise. 0.01. What is the difference between the General Parity Index (GPI) in Ireland in 2002 and the General Parity Index (GPI) in Lithuania in 2005?
Keep it short and to the point. 0.1. What is the difference between the General Parity Index (GPI) in Middle East & North Africa (all income levels) in 2002 and the General Parity Index (GPI) in France in 2006?
Offer a terse response. -0.09. What is the difference between the General Parity Index (GPI) in Middle East & North Africa (all income levels) in 2002 and the General Parity Index (GPI) in Ireland in 2006?
Offer a very short reply. -0.17. What is the difference between the General Parity Index (GPI) in Middle East & North Africa (all income levels) in 2002 and the General Parity Index (GPI) in Lithuania in 2006?
Provide a succinct answer. -0.08. What is the difference between the General Parity Index (GPI) of France in 2002 and the General Parity Index (GPI) of Ireland in 2006?
Provide a short and direct response. -0.08. What is the difference between the General Parity Index (GPI) of France in 2002 and the General Parity Index (GPI) of Lithuania in 2006?
Your response must be concise. 0.01. What is the difference between the General Parity Index (GPI) of Ireland in 2002 and the General Parity Index (GPI) of Lithuania in 2006?
Provide a succinct answer. 0.1. What is the difference between the General Parity Index (GPI) of Middle East & North Africa (all income levels) in 2003 and the General Parity Index (GPI) of France in 2004?
Offer a very short reply. -0.08. What is the difference between the General Parity Index (GPI) in Middle East & North Africa (all income levels) in 2003 and the General Parity Index (GPI) in Ireland in 2004?
Your answer should be compact. -0.16. What is the difference between the General Parity Index (GPI) of Middle East & North Africa (all income levels) in 2003 and the General Parity Index (GPI) of Lithuania in 2004?
Offer a terse response. -0.07. What is the difference between the General Parity Index (GPI) in France in 2003 and the General Parity Index (GPI) in Ireland in 2004?
Provide a short and direct response. -0.07. What is the difference between the General Parity Index (GPI) of France in 2003 and the General Parity Index (GPI) of Lithuania in 2004?
Provide a succinct answer. 0.02. What is the difference between the General Parity Index (GPI) in Ireland in 2003 and the General Parity Index (GPI) in Lithuania in 2004?
Give a very brief answer. 0.1. What is the difference between the General Parity Index (GPI) of Middle East & North Africa (all income levels) in 2003 and the General Parity Index (GPI) of France in 2005?
Make the answer very short. -0.08. What is the difference between the General Parity Index (GPI) of Middle East & North Africa (all income levels) in 2003 and the General Parity Index (GPI) of Ireland in 2005?
Your response must be concise. -0.18. What is the difference between the General Parity Index (GPI) in Middle East & North Africa (all income levels) in 2003 and the General Parity Index (GPI) in Lithuania in 2005?
Your response must be concise. -0.07. What is the difference between the General Parity Index (GPI) of France in 2003 and the General Parity Index (GPI) of Ireland in 2005?
Keep it short and to the point. -0.09. What is the difference between the General Parity Index (GPI) in France in 2003 and the General Parity Index (GPI) in Lithuania in 2005?
Keep it short and to the point. 0.02. What is the difference between the General Parity Index (GPI) of Ireland in 2003 and the General Parity Index (GPI) of Lithuania in 2005?
Your response must be concise. 0.1. What is the difference between the General Parity Index (GPI) of Middle East & North Africa (all income levels) in 2003 and the General Parity Index (GPI) of France in 2006?
Make the answer very short. -0.08. What is the difference between the General Parity Index (GPI) of Middle East & North Africa (all income levels) in 2003 and the General Parity Index (GPI) of Ireland in 2006?
Offer a very short reply. -0.16. What is the difference between the General Parity Index (GPI) of Middle East & North Africa (all income levels) in 2003 and the General Parity Index (GPI) of Lithuania in 2006?
Your answer should be compact. -0.07. What is the difference between the General Parity Index (GPI) of France in 2003 and the General Parity Index (GPI) of Ireland in 2006?
Your answer should be very brief. -0.08. What is the difference between the General Parity Index (GPI) of France in 2003 and the General Parity Index (GPI) of Lithuania in 2006?
Make the answer very short. 0.01. What is the difference between the General Parity Index (GPI) of Ireland in 2003 and the General Parity Index (GPI) of Lithuania in 2006?
Give a very brief answer. 0.09. What is the difference between the General Parity Index (GPI) of Middle East & North Africa (all income levels) in 2004 and the General Parity Index (GPI) of France in 2005?
Provide a short and direct response. -0.08. What is the difference between the General Parity Index (GPI) in Middle East & North Africa (all income levels) in 2004 and the General Parity Index (GPI) in Ireland in 2005?
Your response must be concise. -0.17. What is the difference between the General Parity Index (GPI) in Middle East & North Africa (all income levels) in 2004 and the General Parity Index (GPI) in Lithuania in 2005?
Provide a short and direct response. -0.06. What is the difference between the General Parity Index (GPI) of France in 2004 and the General Parity Index (GPI) of Ireland in 2005?
Your answer should be compact. -0.09. What is the difference between the General Parity Index (GPI) in France in 2004 and the General Parity Index (GPI) in Lithuania in 2005?
Provide a succinct answer. 0.01. What is the difference between the General Parity Index (GPI) of Ireland in 2004 and the General Parity Index (GPI) of Lithuania in 2005?
Ensure brevity in your answer.  0.09. What is the difference between the General Parity Index (GPI) in Middle East & North Africa (all income levels) in 2004 and the General Parity Index (GPI) in France in 2006?
Your answer should be compact. -0.08. What is the difference between the General Parity Index (GPI) in Middle East & North Africa (all income levels) in 2004 and the General Parity Index (GPI) in Ireland in 2006?
Provide a short and direct response. -0.16. What is the difference between the General Parity Index (GPI) in Middle East & North Africa (all income levels) in 2004 and the General Parity Index (GPI) in Lithuania in 2006?
Your response must be concise. -0.07. What is the difference between the General Parity Index (GPI) of France in 2004 and the General Parity Index (GPI) of Ireland in 2006?
Your answer should be very brief. -0.08. What is the difference between the General Parity Index (GPI) in France in 2004 and the General Parity Index (GPI) in Lithuania in 2006?
Offer a very short reply. 0.01. What is the difference between the General Parity Index (GPI) in Ireland in 2004 and the General Parity Index (GPI) in Lithuania in 2006?
Provide a succinct answer. 0.09. What is the difference between the General Parity Index (GPI) of Middle East & North Africa (all income levels) in 2005 and the General Parity Index (GPI) of France in 2006?
Your answer should be compact. -0.07. What is the difference between the General Parity Index (GPI) of Middle East & North Africa (all income levels) in 2005 and the General Parity Index (GPI) of Ireland in 2006?
Offer a terse response. -0.15. What is the difference between the General Parity Index (GPI) of Middle East & North Africa (all income levels) in 2005 and the General Parity Index (GPI) of Lithuania in 2006?
Your answer should be very brief. -0.06. What is the difference between the General Parity Index (GPI) of France in 2005 and the General Parity Index (GPI) of Ireland in 2006?
Ensure brevity in your answer.  -0.08. What is the difference between the General Parity Index (GPI) of France in 2005 and the General Parity Index (GPI) of Lithuania in 2006?
Ensure brevity in your answer.  0.01. What is the difference between the General Parity Index (GPI) of Ireland in 2005 and the General Parity Index (GPI) of Lithuania in 2006?
Provide a short and direct response. 0.1. What is the average General Parity Index (GPI) of Middle East & North Africa (all income levels) per year?
Your answer should be compact. 0.92. What is the average General Parity Index (GPI) of France per year?
Ensure brevity in your answer.  1. What is the average General Parity Index (GPI) of Ireland per year?
Offer a very short reply. 1.08. In the year 1999, what is the difference between the General Parity Index (GPI) in Middle East & North Africa (all income levels) and General Parity Index (GPI) in France?
Offer a terse response. -0.1. In the year 1999, what is the difference between the General Parity Index (GPI) of Middle East & North Africa (all income levels) and General Parity Index (GPI) of Ireland?
Ensure brevity in your answer.  -0.17. In the year 1999, what is the difference between the General Parity Index (GPI) in Middle East & North Africa (all income levels) and General Parity Index (GPI) in Lithuania?
Offer a terse response. -0.11. In the year 1999, what is the difference between the General Parity Index (GPI) in France and General Parity Index (GPI) in Ireland?
Keep it short and to the point. -0.06. In the year 1999, what is the difference between the General Parity Index (GPI) of France and General Parity Index (GPI) of Lithuania?
Your answer should be compact. -0.01. In the year 1999, what is the difference between the General Parity Index (GPI) of Ireland and General Parity Index (GPI) of Lithuania?
Ensure brevity in your answer.  0.06. In the year 2000, what is the difference between the General Parity Index (GPI) in Middle East & North Africa (all income levels) and General Parity Index (GPI) in France?
Provide a succinct answer. -0.1. In the year 2000, what is the difference between the General Parity Index (GPI) of Middle East & North Africa (all income levels) and General Parity Index (GPI) of Ireland?
Provide a short and direct response. -0.18. In the year 2000, what is the difference between the General Parity Index (GPI) of Middle East & North Africa (all income levels) and General Parity Index (GPI) of Lithuania?
Keep it short and to the point. -0.09. In the year 2000, what is the difference between the General Parity Index (GPI) of France and General Parity Index (GPI) of Ireland?
Provide a short and direct response. -0.08. In the year 2000, what is the difference between the General Parity Index (GPI) in France and General Parity Index (GPI) in Lithuania?
Ensure brevity in your answer.  0.01. In the year 2000, what is the difference between the General Parity Index (GPI) in Ireland and General Parity Index (GPI) in Lithuania?
Make the answer very short. 0.09. In the year 2001, what is the difference between the General Parity Index (GPI) in Middle East & North Africa (all income levels) and General Parity Index (GPI) in France?
Your response must be concise. -0.1. In the year 2001, what is the difference between the General Parity Index (GPI) in Middle East & North Africa (all income levels) and General Parity Index (GPI) in Ireland?
Offer a terse response. -0.18. In the year 2001, what is the difference between the General Parity Index (GPI) in Middle East & North Africa (all income levels) and General Parity Index (GPI) in Lithuania?
Your answer should be compact. -0.08. In the year 2001, what is the difference between the General Parity Index (GPI) in France and General Parity Index (GPI) in Ireland?
Provide a succinct answer. -0.08. In the year 2001, what is the difference between the General Parity Index (GPI) in France and General Parity Index (GPI) in Lithuania?
Your answer should be very brief. 0.01. In the year 2001, what is the difference between the General Parity Index (GPI) of Ireland and General Parity Index (GPI) of Lithuania?
Provide a succinct answer. 0.1. In the year 2002, what is the difference between the General Parity Index (GPI) in Middle East & North Africa (all income levels) and General Parity Index (GPI) in France?
Offer a terse response. -0.09. In the year 2002, what is the difference between the General Parity Index (GPI) of Middle East & North Africa (all income levels) and General Parity Index (GPI) of Ireland?
Make the answer very short. -0.18. In the year 2002, what is the difference between the General Parity Index (GPI) in Middle East & North Africa (all income levels) and General Parity Index (GPI) in Lithuania?
Offer a very short reply. -0.07. In the year 2002, what is the difference between the General Parity Index (GPI) of France and General Parity Index (GPI) of Ireland?
Your answer should be compact. -0.09. In the year 2002, what is the difference between the General Parity Index (GPI) in France and General Parity Index (GPI) in Lithuania?
Your answer should be compact. 0.02. In the year 2002, what is the difference between the General Parity Index (GPI) of Ireland and General Parity Index (GPI) of Lithuania?
Make the answer very short. 0.11. In the year 2003, what is the difference between the General Parity Index (GPI) in Middle East & North Africa (all income levels) and General Parity Index (GPI) in France?
Ensure brevity in your answer.  -0.09. In the year 2003, what is the difference between the General Parity Index (GPI) in Middle East & North Africa (all income levels) and General Parity Index (GPI) in Ireland?
Give a very brief answer. -0.17. In the year 2003, what is the difference between the General Parity Index (GPI) in Middle East & North Africa (all income levels) and General Parity Index (GPI) in Lithuania?
Keep it short and to the point. -0.06. In the year 2003, what is the difference between the General Parity Index (GPI) of France and General Parity Index (GPI) of Ireland?
Offer a very short reply. -0.08. In the year 2003, what is the difference between the General Parity Index (GPI) of France and General Parity Index (GPI) of Lithuania?
Provide a succinct answer. 0.03. In the year 2003, what is the difference between the General Parity Index (GPI) of Ireland and General Parity Index (GPI) of Lithuania?
Your response must be concise. 0.11. In the year 2004, what is the difference between the General Parity Index (GPI) in Middle East & North Africa (all income levels) and General Parity Index (GPI) in France?
Ensure brevity in your answer.  -0.08. In the year 2004, what is the difference between the General Parity Index (GPI) of Middle East & North Africa (all income levels) and General Parity Index (GPI) of Ireland?
Offer a very short reply. -0.15. In the year 2004, what is the difference between the General Parity Index (GPI) of Middle East & North Africa (all income levels) and General Parity Index (GPI) of Lithuania?
Offer a terse response. -0.06. In the year 2004, what is the difference between the General Parity Index (GPI) in France and General Parity Index (GPI) in Ireland?
Ensure brevity in your answer.  -0.08. In the year 2004, what is the difference between the General Parity Index (GPI) of France and General Parity Index (GPI) of Lithuania?
Provide a succinct answer. 0.01. In the year 2004, what is the difference between the General Parity Index (GPI) in Ireland and General Parity Index (GPI) in Lithuania?
Ensure brevity in your answer.  0.09. In the year 2005, what is the difference between the General Parity Index (GPI) of Middle East & North Africa (all income levels) and General Parity Index (GPI) of France?
Your answer should be very brief. -0.07. In the year 2005, what is the difference between the General Parity Index (GPI) in Middle East & North Africa (all income levels) and General Parity Index (GPI) in Ireland?
Keep it short and to the point. -0.16. In the year 2005, what is the difference between the General Parity Index (GPI) in Middle East & North Africa (all income levels) and General Parity Index (GPI) in Lithuania?
Keep it short and to the point. -0.05. In the year 2005, what is the difference between the General Parity Index (GPI) in France and General Parity Index (GPI) in Ireland?
Provide a succinct answer. -0.09. In the year 2005, what is the difference between the General Parity Index (GPI) in France and General Parity Index (GPI) in Lithuania?
Provide a short and direct response. 0.01. In the year 2005, what is the difference between the General Parity Index (GPI) in Ireland and General Parity Index (GPI) in Lithuania?
Offer a terse response. 0.11. In the year 2006, what is the difference between the General Parity Index (GPI) in Middle East & North Africa (all income levels) and General Parity Index (GPI) in France?
Offer a terse response. -0.06. In the year 2006, what is the difference between the General Parity Index (GPI) in Middle East & North Africa (all income levels) and General Parity Index (GPI) in Ireland?
Your answer should be compact. -0.14. In the year 2006, what is the difference between the General Parity Index (GPI) in Middle East & North Africa (all income levels) and General Parity Index (GPI) in Lithuania?
Provide a succinct answer. -0.05. In the year 2006, what is the difference between the General Parity Index (GPI) in France and General Parity Index (GPI) in Ireland?
Offer a very short reply. -0.08. In the year 2006, what is the difference between the General Parity Index (GPI) of France and General Parity Index (GPI) of Lithuania?
Provide a short and direct response. 0.01. In the year 2006, what is the difference between the General Parity Index (GPI) in Ireland and General Parity Index (GPI) in Lithuania?
Provide a succinct answer. 0.09. What is the ratio of the General Parity Index (GPI) of Middle East & North Africa (all income levels) in 1999 to that in 2000?
Keep it short and to the point. 0.99. What is the ratio of the General Parity Index (GPI) of Ireland in 1999 to that in 2000?
Make the answer very short. 0.98. What is the ratio of the General Parity Index (GPI) of Lithuania in 1999 to that in 2000?
Provide a short and direct response. 1.01. What is the ratio of the General Parity Index (GPI) of France in 1999 to that in 2001?
Provide a succinct answer. 0.99. What is the ratio of the General Parity Index (GPI) in Ireland in 1999 to that in 2001?
Your answer should be very brief. 0.98. What is the ratio of the General Parity Index (GPI) in Lithuania in 1999 to that in 2001?
Make the answer very short. 1.01. What is the ratio of the General Parity Index (GPI) of Middle East & North Africa (all income levels) in 1999 to that in 2002?
Provide a succinct answer. 0.98. What is the ratio of the General Parity Index (GPI) of Ireland in 1999 to that in 2002?
Make the answer very short. 0.97. What is the ratio of the General Parity Index (GPI) in Lithuania in 1999 to that in 2002?
Offer a very short reply. 1.02. What is the ratio of the General Parity Index (GPI) in Middle East & North Africa (all income levels) in 1999 to that in 2003?
Ensure brevity in your answer.  0.97. What is the ratio of the General Parity Index (GPI) of Ireland in 1999 to that in 2003?
Offer a terse response. 0.98. What is the ratio of the General Parity Index (GPI) of Lithuania in 1999 to that in 2003?
Ensure brevity in your answer.  1.03. What is the ratio of the General Parity Index (GPI) of Middle East & North Africa (all income levels) in 1999 to that in 2004?
Your response must be concise. 0.97. What is the ratio of the General Parity Index (GPI) of Ireland in 1999 to that in 2004?
Your answer should be compact. 0.98. What is the ratio of the General Parity Index (GPI) in Lithuania in 1999 to that in 2004?
Your response must be concise. 1.02. What is the ratio of the General Parity Index (GPI) of Middle East & North Africa (all income levels) in 1999 to that in 2005?
Offer a very short reply. 0.96. What is the ratio of the General Parity Index (GPI) in France in 1999 to that in 2005?
Provide a succinct answer. 1. What is the ratio of the General Parity Index (GPI) of Ireland in 1999 to that in 2005?
Ensure brevity in your answer.  0.97. What is the ratio of the General Parity Index (GPI) of Lithuania in 1999 to that in 2005?
Your answer should be compact. 1.02. What is the ratio of the General Parity Index (GPI) of Middle East & North Africa (all income levels) in 1999 to that in 2006?
Your answer should be very brief. 0.95. What is the ratio of the General Parity Index (GPI) in France in 1999 to that in 2006?
Offer a very short reply. 1. What is the ratio of the General Parity Index (GPI) in Ireland in 1999 to that in 2006?
Offer a very short reply. 0.98. What is the ratio of the General Parity Index (GPI) of Lithuania in 1999 to that in 2006?
Offer a very short reply. 1.01. What is the ratio of the General Parity Index (GPI) in Lithuania in 2000 to that in 2001?
Ensure brevity in your answer.  1. What is the ratio of the General Parity Index (GPI) in Middle East & North Africa (all income levels) in 2000 to that in 2002?
Make the answer very short. 0.99. What is the ratio of the General Parity Index (GPI) in France in 2000 to that in 2002?
Give a very brief answer. 1. What is the ratio of the General Parity Index (GPI) in Ireland in 2000 to that in 2002?
Provide a short and direct response. 0.99. What is the ratio of the General Parity Index (GPI) in Lithuania in 2000 to that in 2002?
Provide a succinct answer. 1.01. What is the ratio of the General Parity Index (GPI) in Middle East & North Africa (all income levels) in 2000 to that in 2003?
Make the answer very short. 0.98. What is the ratio of the General Parity Index (GPI) of France in 2000 to that in 2003?
Provide a short and direct response. 1. What is the ratio of the General Parity Index (GPI) of Ireland in 2000 to that in 2003?
Your answer should be very brief. 1. What is the ratio of the General Parity Index (GPI) of Lithuania in 2000 to that in 2003?
Provide a succinct answer. 1.02. What is the ratio of the General Parity Index (GPI) of Middle East & North Africa (all income levels) in 2000 to that in 2004?
Your answer should be compact. 0.98. What is the ratio of the General Parity Index (GPI) in France in 2000 to that in 2004?
Provide a succinct answer. 1. What is the ratio of the General Parity Index (GPI) of Ireland in 2000 to that in 2004?
Your answer should be compact. 1. What is the ratio of the General Parity Index (GPI) of Middle East & North Africa (all income levels) in 2000 to that in 2005?
Offer a terse response. 0.97. What is the ratio of the General Parity Index (GPI) of France in 2000 to that in 2005?
Offer a very short reply. 1. What is the ratio of the General Parity Index (GPI) of Lithuania in 2000 to that in 2005?
Provide a succinct answer. 1. What is the ratio of the General Parity Index (GPI) of Middle East & North Africa (all income levels) in 2000 to that in 2006?
Offer a terse response. 0.96. What is the ratio of the General Parity Index (GPI) of Middle East & North Africa (all income levels) in 2001 to that in 2002?
Your response must be concise. 1. What is the ratio of the General Parity Index (GPI) in France in 2001 to that in 2002?
Provide a short and direct response. 1. What is the ratio of the General Parity Index (GPI) in Ireland in 2001 to that in 2002?
Provide a succinct answer. 1. What is the ratio of the General Parity Index (GPI) in Lithuania in 2001 to that in 2002?
Your response must be concise. 1.01. What is the ratio of the General Parity Index (GPI) in Ireland in 2001 to that in 2003?
Keep it short and to the point. 1. What is the ratio of the General Parity Index (GPI) of Lithuania in 2001 to that in 2003?
Give a very brief answer. 1.01. What is the ratio of the General Parity Index (GPI) of Middle East & North Africa (all income levels) in 2001 to that in 2004?
Your answer should be compact. 0.98. What is the ratio of the General Parity Index (GPI) of Ireland in 2001 to that in 2004?
Offer a very short reply. 1.01. What is the ratio of the General Parity Index (GPI) in Middle East & North Africa (all income levels) in 2001 to that in 2005?
Keep it short and to the point. 0.97. What is the ratio of the General Parity Index (GPI) of France in 2001 to that in 2005?
Your response must be concise. 1. What is the ratio of the General Parity Index (GPI) in Lithuania in 2001 to that in 2005?
Provide a short and direct response. 1. What is the ratio of the General Parity Index (GPI) of Middle East & North Africa (all income levels) in 2001 to that in 2006?
Offer a very short reply. 0.97. What is the ratio of the General Parity Index (GPI) of Ireland in 2001 to that in 2006?
Your answer should be very brief. 1.01. What is the ratio of the General Parity Index (GPI) in Middle East & North Africa (all income levels) in 2002 to that in 2003?
Give a very brief answer. 0.99. What is the ratio of the General Parity Index (GPI) of France in 2002 to that in 2003?
Keep it short and to the point. 1. What is the ratio of the General Parity Index (GPI) in Lithuania in 2002 to that in 2003?
Make the answer very short. 1. What is the ratio of the General Parity Index (GPI) in Middle East & North Africa (all income levels) in 2002 to that in 2004?
Keep it short and to the point. 0.99. What is the ratio of the General Parity Index (GPI) of France in 2002 to that in 2004?
Give a very brief answer. 1. What is the ratio of the General Parity Index (GPI) in Ireland in 2002 to that in 2004?
Provide a short and direct response. 1.01. What is the ratio of the General Parity Index (GPI) in Lithuania in 2002 to that in 2004?
Your answer should be very brief. 0.99. What is the ratio of the General Parity Index (GPI) of Middle East & North Africa (all income levels) in 2002 to that in 2005?
Your answer should be compact. 0.98. What is the ratio of the General Parity Index (GPI) of Ireland in 2002 to that in 2005?
Make the answer very short. 1. What is the ratio of the General Parity Index (GPI) of Lithuania in 2002 to that in 2005?
Ensure brevity in your answer.  0.99. What is the ratio of the General Parity Index (GPI) of Middle East & North Africa (all income levels) in 2002 to that in 2006?
Your response must be concise. 0.97. What is the ratio of the General Parity Index (GPI) in Ireland in 2003 to that in 2004?
Your answer should be compact. 1.01. What is the ratio of the General Parity Index (GPI) in Lithuania in 2003 to that in 2004?
Keep it short and to the point. 0.99. What is the ratio of the General Parity Index (GPI) in France in 2003 to that in 2005?
Your answer should be very brief. 1. What is the ratio of the General Parity Index (GPI) of Ireland in 2003 to that in 2005?
Your answer should be very brief. 0.99. What is the ratio of the General Parity Index (GPI) of Lithuania in 2003 to that in 2005?
Your answer should be very brief. 0.99. What is the ratio of the General Parity Index (GPI) of Middle East & North Africa (all income levels) in 2003 to that in 2006?
Your answer should be very brief. 0.98. What is the ratio of the General Parity Index (GPI) of France in 2003 to that in 2006?
Keep it short and to the point. 1. What is the ratio of the General Parity Index (GPI) in Lithuania in 2003 to that in 2006?
Keep it short and to the point. 0.98. What is the ratio of the General Parity Index (GPI) in Middle East & North Africa (all income levels) in 2004 to that in 2005?
Provide a succinct answer. 0.99. What is the ratio of the General Parity Index (GPI) in France in 2004 to that in 2005?
Provide a short and direct response. 1. What is the ratio of the General Parity Index (GPI) of Ireland in 2004 to that in 2005?
Your answer should be compact. 0.99. What is the ratio of the General Parity Index (GPI) of Middle East & North Africa (all income levels) in 2004 to that in 2006?
Offer a terse response. 0.98. What is the ratio of the General Parity Index (GPI) in Ireland in 2004 to that in 2006?
Ensure brevity in your answer.  1. What is the ratio of the General Parity Index (GPI) of France in 2005 to that in 2006?
Provide a short and direct response. 1. What is the ratio of the General Parity Index (GPI) of Ireland in 2005 to that in 2006?
Ensure brevity in your answer.  1.01. What is the ratio of the General Parity Index (GPI) in Lithuania in 2005 to that in 2006?
Provide a short and direct response. 1. What is the difference between the highest and the second highest General Parity Index (GPI) of Middle East & North Africa (all income levels)?
Offer a very short reply. 0.01. What is the difference between the highest and the second highest General Parity Index (GPI) of France?
Give a very brief answer. 0. What is the difference between the highest and the second highest General Parity Index (GPI) of Ireland?
Your answer should be very brief. 0. What is the difference between the highest and the second highest General Parity Index (GPI) of Lithuania?
Keep it short and to the point. 0.01. What is the difference between the highest and the lowest General Parity Index (GPI) of Middle East & North Africa (all income levels)?
Your answer should be very brief. 0.05. What is the difference between the highest and the lowest General Parity Index (GPI) in France?
Make the answer very short. 0.01. What is the difference between the highest and the lowest General Parity Index (GPI) in Ireland?
Your answer should be very brief. 0.03. What is the difference between the highest and the lowest General Parity Index (GPI) of Lithuania?
Offer a very short reply. 0.03. 